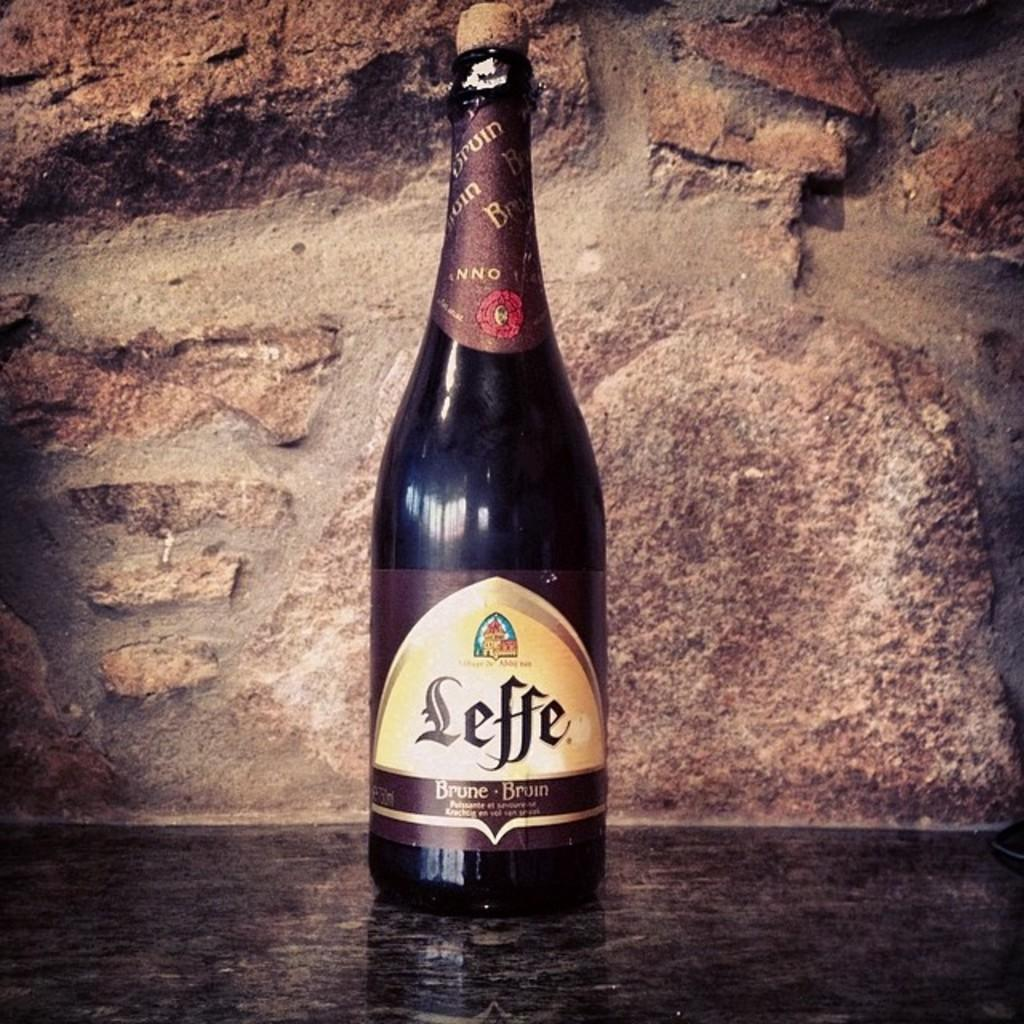<image>
Write a terse but informative summary of the picture. The label on a bottle of beer says Leffe. 